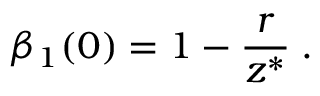<formula> <loc_0><loc_0><loc_500><loc_500>\beta _ { 1 } ( 0 ) = 1 - \frac { r } { z ^ { * } } \, .</formula> 